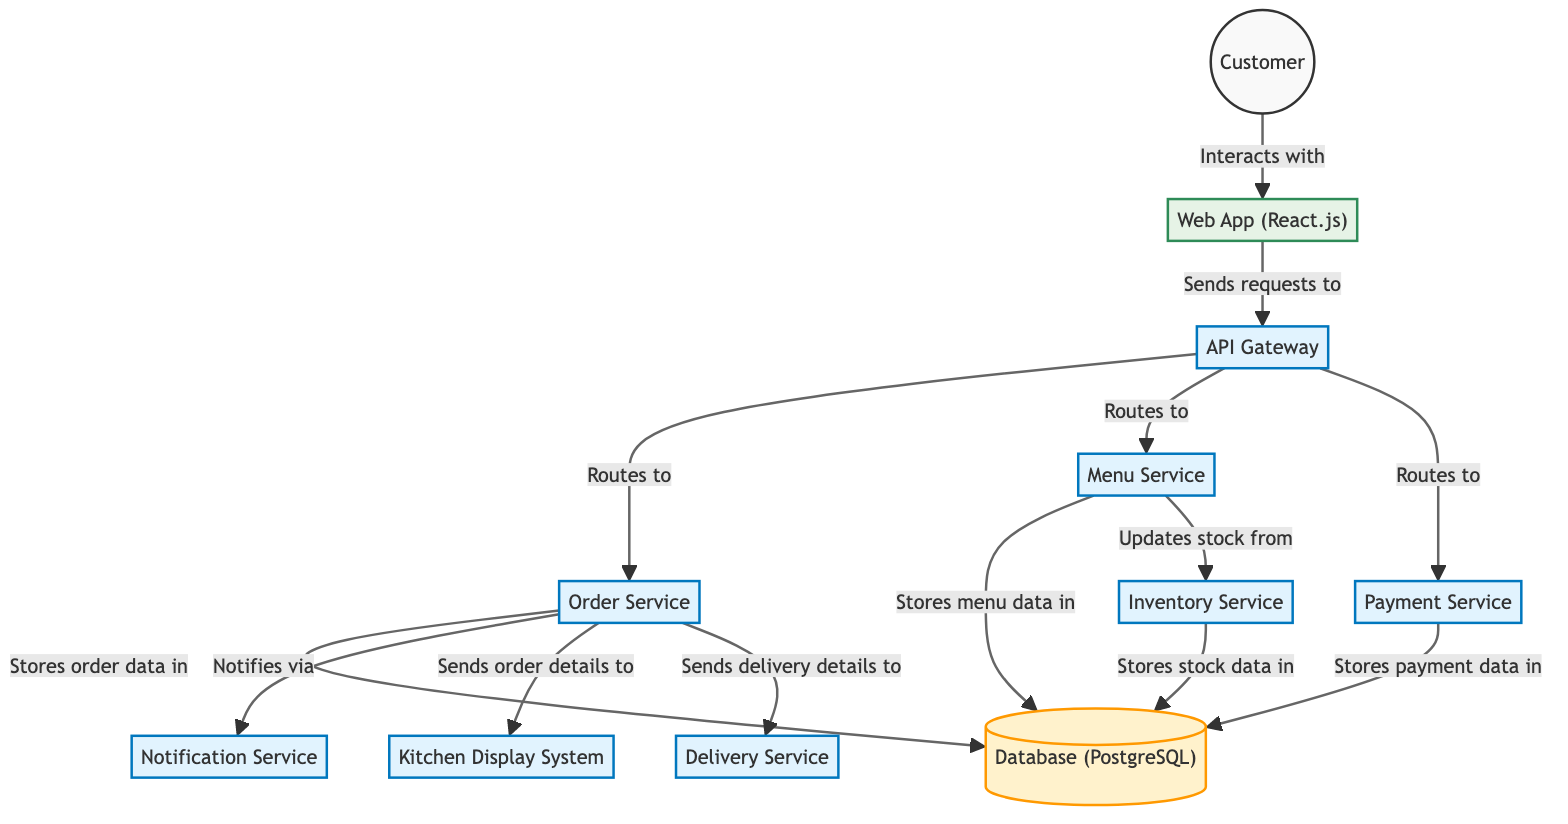What is the primary interface for the customer? The primary interface for the customer, as shown in the diagram, is the "Web App (React.js)", through which the customer interacts and sends requests.
Answer: Web App (React.js) How many services are there in total? By counting the nodes labeled as services in the diagram, there are eight distinct services: API Gateway, Order Service, Menu Service, Notification Service, Payment Service, Kitchen Display System, Inventory Service, and Delivery Service.
Answer: Eight Which service is responsible for notifying about orders? The service responsible for notifying about orders, as illustrated in the diagram, is the "Notification Service," which receives notifications from the Order Service.
Answer: Notification Service Where does the Order Service store the order data? According to the diagram, the Order Service stores the order data in the "Database (PostgreSQL)," indicating the connection for data storage.
Answer: Database (PostgreSQL) What is the flow of data from the customer to the kitchen display system? The flow begins with the customer interacting with the Web App, which sends requests to the API Gateway. From there, the API Gateway routes the request to the Order Service, which then sends the order details to the Kitchen Display System.
Answer: Customer → Web App → API Gateway → Order Service → Kitchen Display System Which service updates the stock levels? The service responsible for updating the stock levels is the "Menu Service," which interacts with the "Inventory Service" to update stock data.
Answer: Menu Service What system does the payment service communicate with to store payment information? The payment service communicates with the "Database (PostgreSQL)" to store payment data as indicated in the flowchart.
Answer: Database (PostgreSQL) What does the inventory service store? The inventory service stores stock data, as shown in the diagram, which is linked to both the Menu Service and the Database.
Answer: Stock data How does the Order Service communicate with the Delivery Service? The Order Service communicates directly with the Delivery Service by sending delivery details as indicated by the arrow labeled "Sends delivery details to" in the diagram.
Answer: Sends delivery details to What role does the API Gateway play in this system? The API Gateway serves as a routing mechanism that directs incoming requests from the Web App to the appropriate backend service, managing the flow of data in the system.
Answer: Routing mechanism 